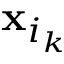Convert formula to latex. <formula><loc_0><loc_0><loc_500><loc_500>x _ { i _ { k } }</formula> 